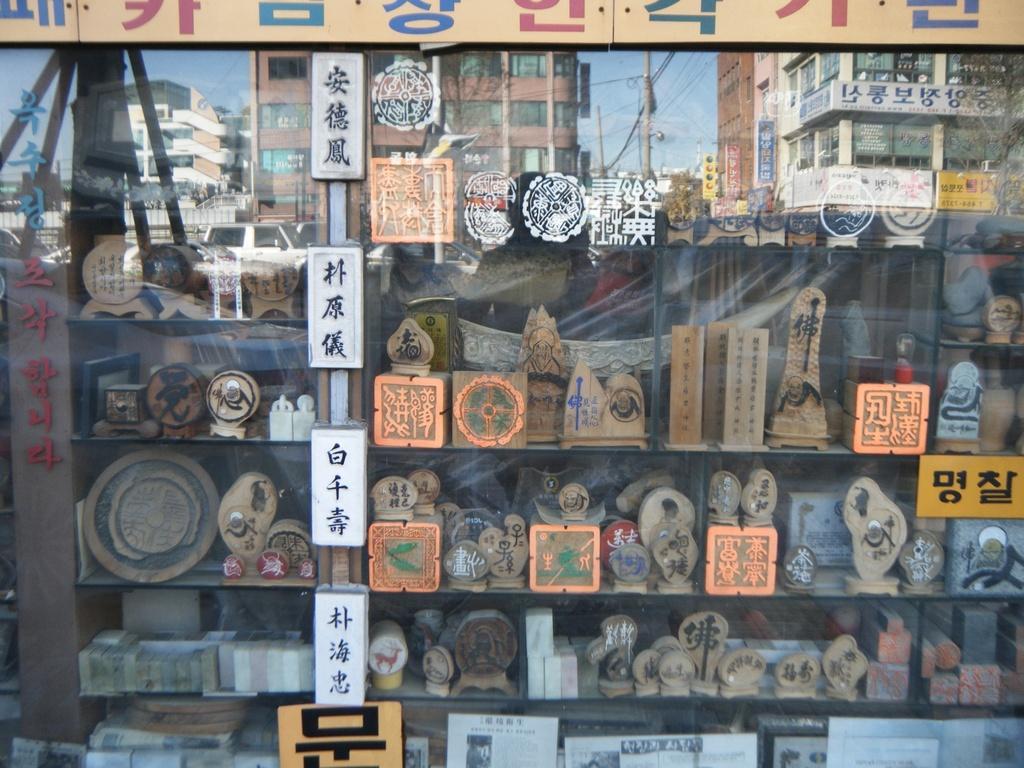How would you summarize this image in a sentence or two? This picture is taken from the outside of the glass window. In this image, on the left side, we can see a pole. In the glass window, we can see a shelf with some objects, in the glass window, we can also see some buildings, electric pole, electric wires, cars. At the top, we can see a sky. 